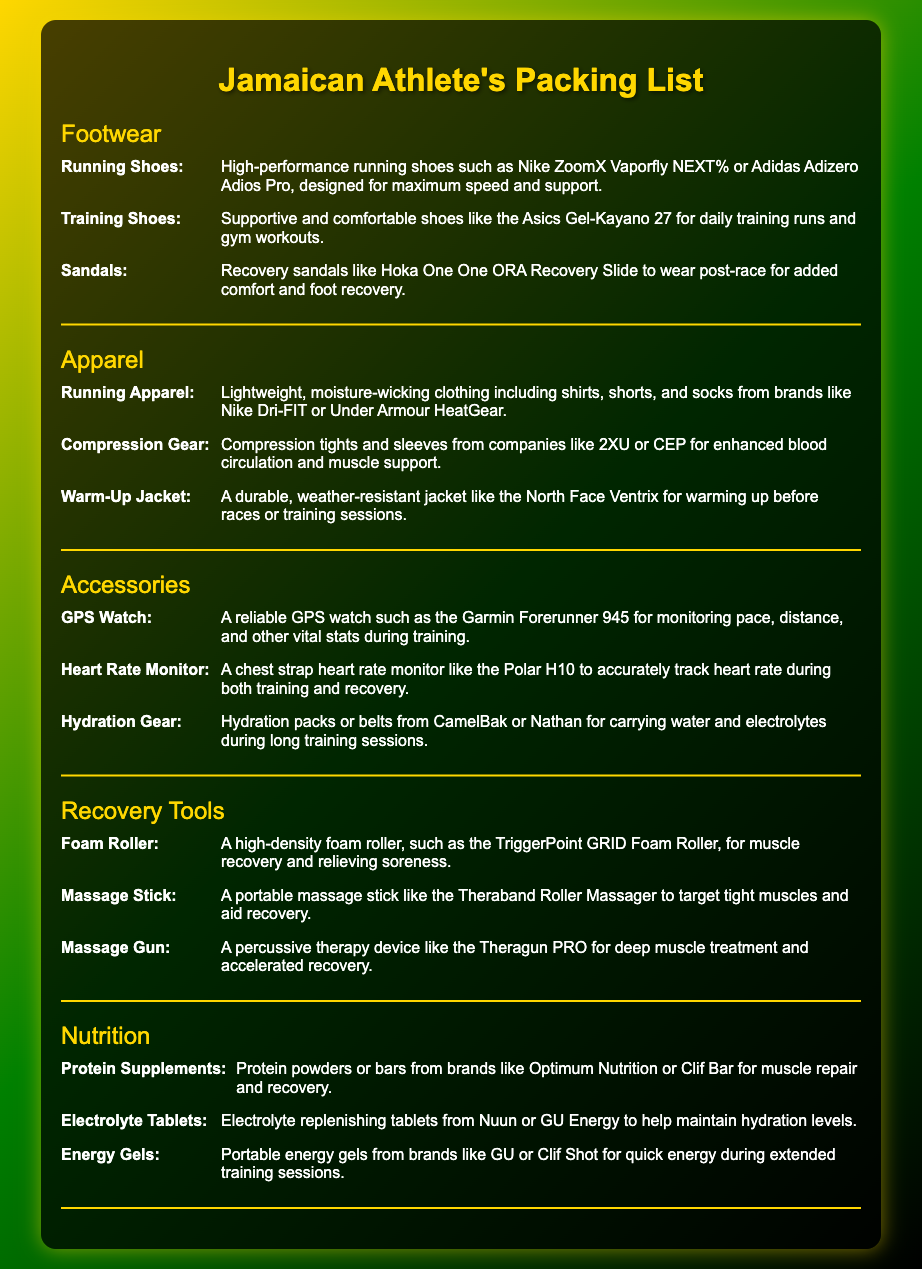what type of running shoes are mentioned? The packing list specifies high-performance running shoes designed for speed and support.
Answer: Nike ZoomX Vaporfly NEXT% or Adidas Adizero Adios Pro how many types of recovery tools are listed? The document features a category "Recovery Tools" with three distinct items.
Answer: Three what are the features of compression gear? The compression gear is described as enhancing blood circulation and providing muscle support.
Answer: Enhanced blood circulation and muscle support which brand is mentioned for hydration gear? The hydration gear items are associated with specific brands recommended for carrying water and electrolytes.
Answer: CamelBak or Nathan what is the purpose of the foam roller? The foam roller is used for a specific function related to fitness and recovery.
Answer: Muscle recovery and relieving soreness how many different categories are included in the packing list? The document divides the packing list into several sections for organization.
Answer: Five 